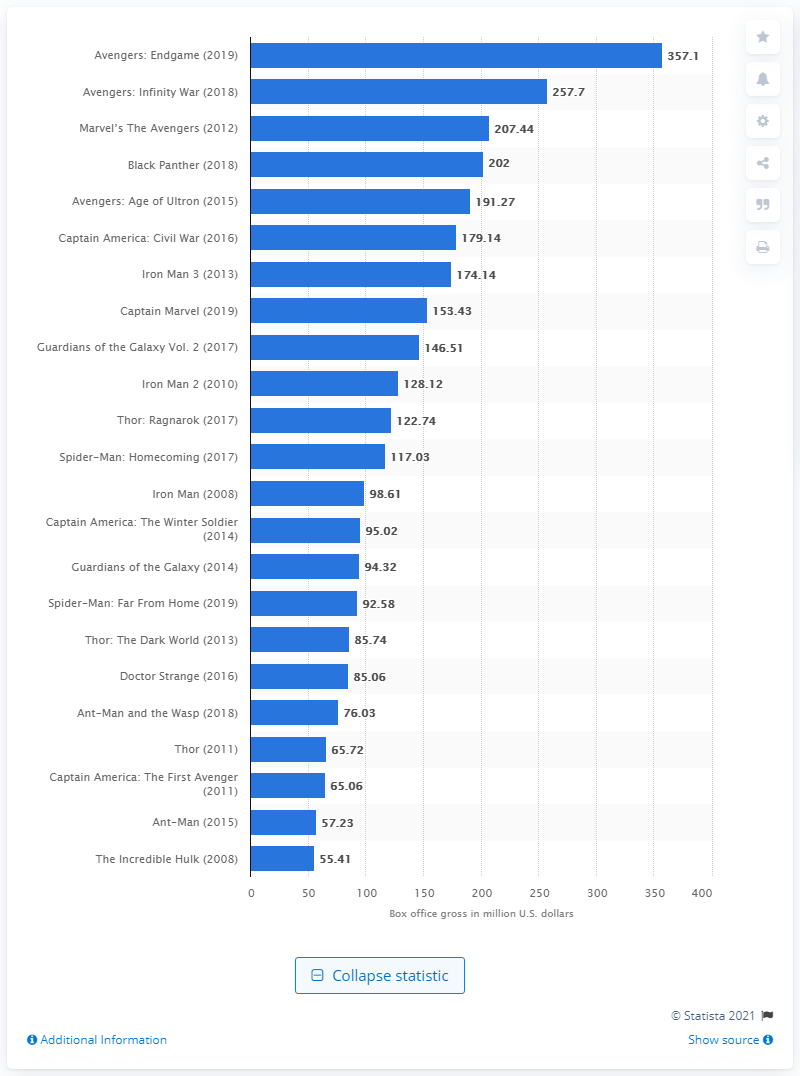Identify some key points in this picture. The domestic box office revenue generated by 'Avengers: Endgame' was 357.1 million. Avengers: Infinity War made an estimated 257.7 million dollars in its first weekend in theaters. 